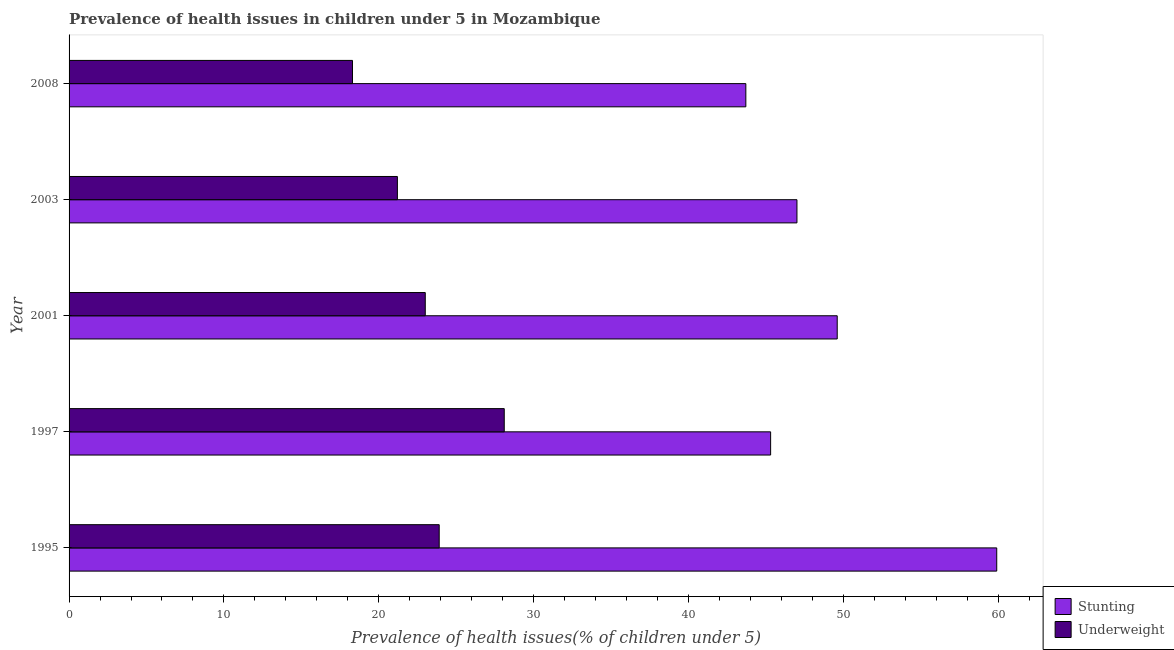Are the number of bars on each tick of the Y-axis equal?
Keep it short and to the point. Yes. How many bars are there on the 5th tick from the bottom?
Ensure brevity in your answer.  2. What is the percentage of stunted children in 1995?
Offer a very short reply. 59.9. Across all years, what is the maximum percentage of stunted children?
Keep it short and to the point. 59.9. Across all years, what is the minimum percentage of stunted children?
Ensure brevity in your answer.  43.7. In which year was the percentage of stunted children maximum?
Your response must be concise. 1995. What is the total percentage of stunted children in the graph?
Your response must be concise. 245.5. What is the difference between the percentage of stunted children in 1997 and that in 2008?
Give a very brief answer. 1.6. What is the difference between the percentage of stunted children in 1995 and the percentage of underweight children in 2003?
Offer a very short reply. 38.7. What is the average percentage of stunted children per year?
Your response must be concise. 49.1. What is the ratio of the percentage of stunted children in 2001 to that in 2003?
Make the answer very short. 1.05. Is the percentage of stunted children in 1997 less than that in 2001?
Make the answer very short. Yes. Is the difference between the percentage of stunted children in 2001 and 2008 greater than the difference between the percentage of underweight children in 2001 and 2008?
Your answer should be very brief. Yes. Is the sum of the percentage of underweight children in 1995 and 2008 greater than the maximum percentage of stunted children across all years?
Ensure brevity in your answer.  No. What does the 1st bar from the top in 1997 represents?
Your answer should be very brief. Underweight. What does the 2nd bar from the bottom in 1995 represents?
Give a very brief answer. Underweight. How many bars are there?
Make the answer very short. 10. How many years are there in the graph?
Your response must be concise. 5. What is the difference between two consecutive major ticks on the X-axis?
Ensure brevity in your answer.  10. Are the values on the major ticks of X-axis written in scientific E-notation?
Make the answer very short. No. Does the graph contain grids?
Your response must be concise. No. How many legend labels are there?
Your answer should be very brief. 2. How are the legend labels stacked?
Make the answer very short. Vertical. What is the title of the graph?
Keep it short and to the point. Prevalence of health issues in children under 5 in Mozambique. What is the label or title of the X-axis?
Your response must be concise. Prevalence of health issues(% of children under 5). What is the Prevalence of health issues(% of children under 5) in Stunting in 1995?
Offer a very short reply. 59.9. What is the Prevalence of health issues(% of children under 5) of Underweight in 1995?
Provide a succinct answer. 23.9. What is the Prevalence of health issues(% of children under 5) of Stunting in 1997?
Offer a terse response. 45.3. What is the Prevalence of health issues(% of children under 5) in Underweight in 1997?
Make the answer very short. 28.1. What is the Prevalence of health issues(% of children under 5) in Stunting in 2001?
Your answer should be very brief. 49.6. What is the Prevalence of health issues(% of children under 5) in Underweight in 2001?
Provide a succinct answer. 23. What is the Prevalence of health issues(% of children under 5) of Underweight in 2003?
Your response must be concise. 21.2. What is the Prevalence of health issues(% of children under 5) of Stunting in 2008?
Provide a short and direct response. 43.7. What is the Prevalence of health issues(% of children under 5) of Underweight in 2008?
Your answer should be compact. 18.3. Across all years, what is the maximum Prevalence of health issues(% of children under 5) in Stunting?
Offer a very short reply. 59.9. Across all years, what is the maximum Prevalence of health issues(% of children under 5) in Underweight?
Your answer should be compact. 28.1. Across all years, what is the minimum Prevalence of health issues(% of children under 5) in Stunting?
Ensure brevity in your answer.  43.7. Across all years, what is the minimum Prevalence of health issues(% of children under 5) in Underweight?
Ensure brevity in your answer.  18.3. What is the total Prevalence of health issues(% of children under 5) in Stunting in the graph?
Your answer should be very brief. 245.5. What is the total Prevalence of health issues(% of children under 5) of Underweight in the graph?
Your response must be concise. 114.5. What is the difference between the Prevalence of health issues(% of children under 5) in Underweight in 1995 and that in 1997?
Keep it short and to the point. -4.2. What is the difference between the Prevalence of health issues(% of children under 5) in Stunting in 1995 and that in 2001?
Make the answer very short. 10.3. What is the difference between the Prevalence of health issues(% of children under 5) of Underweight in 1995 and that in 2001?
Make the answer very short. 0.9. What is the difference between the Prevalence of health issues(% of children under 5) of Stunting in 1995 and that in 2003?
Your response must be concise. 12.9. What is the difference between the Prevalence of health issues(% of children under 5) of Underweight in 1995 and that in 2003?
Offer a terse response. 2.7. What is the difference between the Prevalence of health issues(% of children under 5) of Stunting in 1995 and that in 2008?
Provide a short and direct response. 16.2. What is the difference between the Prevalence of health issues(% of children under 5) of Underweight in 1995 and that in 2008?
Make the answer very short. 5.6. What is the difference between the Prevalence of health issues(% of children under 5) of Underweight in 1997 and that in 2003?
Your answer should be compact. 6.9. What is the difference between the Prevalence of health issues(% of children under 5) of Underweight in 1997 and that in 2008?
Provide a short and direct response. 9.8. What is the difference between the Prevalence of health issues(% of children under 5) in Stunting in 2001 and that in 2003?
Offer a very short reply. 2.6. What is the difference between the Prevalence of health issues(% of children under 5) in Underweight in 2001 and that in 2008?
Offer a terse response. 4.7. What is the difference between the Prevalence of health issues(% of children under 5) of Stunting in 1995 and the Prevalence of health issues(% of children under 5) of Underweight in 1997?
Provide a short and direct response. 31.8. What is the difference between the Prevalence of health issues(% of children under 5) of Stunting in 1995 and the Prevalence of health issues(% of children under 5) of Underweight in 2001?
Give a very brief answer. 36.9. What is the difference between the Prevalence of health issues(% of children under 5) of Stunting in 1995 and the Prevalence of health issues(% of children under 5) of Underweight in 2003?
Your answer should be compact. 38.7. What is the difference between the Prevalence of health issues(% of children under 5) in Stunting in 1995 and the Prevalence of health issues(% of children under 5) in Underweight in 2008?
Provide a succinct answer. 41.6. What is the difference between the Prevalence of health issues(% of children under 5) of Stunting in 1997 and the Prevalence of health issues(% of children under 5) of Underweight in 2001?
Your response must be concise. 22.3. What is the difference between the Prevalence of health issues(% of children under 5) in Stunting in 1997 and the Prevalence of health issues(% of children under 5) in Underweight in 2003?
Offer a very short reply. 24.1. What is the difference between the Prevalence of health issues(% of children under 5) in Stunting in 1997 and the Prevalence of health issues(% of children under 5) in Underweight in 2008?
Provide a short and direct response. 27. What is the difference between the Prevalence of health issues(% of children under 5) of Stunting in 2001 and the Prevalence of health issues(% of children under 5) of Underweight in 2003?
Give a very brief answer. 28.4. What is the difference between the Prevalence of health issues(% of children under 5) in Stunting in 2001 and the Prevalence of health issues(% of children under 5) in Underweight in 2008?
Offer a very short reply. 31.3. What is the difference between the Prevalence of health issues(% of children under 5) in Stunting in 2003 and the Prevalence of health issues(% of children under 5) in Underweight in 2008?
Your answer should be very brief. 28.7. What is the average Prevalence of health issues(% of children under 5) of Stunting per year?
Keep it short and to the point. 49.1. What is the average Prevalence of health issues(% of children under 5) in Underweight per year?
Offer a terse response. 22.9. In the year 2001, what is the difference between the Prevalence of health issues(% of children under 5) of Stunting and Prevalence of health issues(% of children under 5) of Underweight?
Keep it short and to the point. 26.6. In the year 2003, what is the difference between the Prevalence of health issues(% of children under 5) in Stunting and Prevalence of health issues(% of children under 5) in Underweight?
Make the answer very short. 25.8. In the year 2008, what is the difference between the Prevalence of health issues(% of children under 5) of Stunting and Prevalence of health issues(% of children under 5) of Underweight?
Offer a very short reply. 25.4. What is the ratio of the Prevalence of health issues(% of children under 5) of Stunting in 1995 to that in 1997?
Keep it short and to the point. 1.32. What is the ratio of the Prevalence of health issues(% of children under 5) of Underweight in 1995 to that in 1997?
Keep it short and to the point. 0.85. What is the ratio of the Prevalence of health issues(% of children under 5) of Stunting in 1995 to that in 2001?
Make the answer very short. 1.21. What is the ratio of the Prevalence of health issues(% of children under 5) in Underweight in 1995 to that in 2001?
Make the answer very short. 1.04. What is the ratio of the Prevalence of health issues(% of children under 5) of Stunting in 1995 to that in 2003?
Make the answer very short. 1.27. What is the ratio of the Prevalence of health issues(% of children under 5) in Underweight in 1995 to that in 2003?
Ensure brevity in your answer.  1.13. What is the ratio of the Prevalence of health issues(% of children under 5) in Stunting in 1995 to that in 2008?
Your answer should be compact. 1.37. What is the ratio of the Prevalence of health issues(% of children under 5) of Underweight in 1995 to that in 2008?
Give a very brief answer. 1.31. What is the ratio of the Prevalence of health issues(% of children under 5) in Stunting in 1997 to that in 2001?
Make the answer very short. 0.91. What is the ratio of the Prevalence of health issues(% of children under 5) of Underweight in 1997 to that in 2001?
Your answer should be very brief. 1.22. What is the ratio of the Prevalence of health issues(% of children under 5) of Stunting in 1997 to that in 2003?
Make the answer very short. 0.96. What is the ratio of the Prevalence of health issues(% of children under 5) in Underweight in 1997 to that in 2003?
Keep it short and to the point. 1.33. What is the ratio of the Prevalence of health issues(% of children under 5) in Stunting in 1997 to that in 2008?
Keep it short and to the point. 1.04. What is the ratio of the Prevalence of health issues(% of children under 5) of Underweight in 1997 to that in 2008?
Give a very brief answer. 1.54. What is the ratio of the Prevalence of health issues(% of children under 5) in Stunting in 2001 to that in 2003?
Make the answer very short. 1.06. What is the ratio of the Prevalence of health issues(% of children under 5) of Underweight in 2001 to that in 2003?
Offer a very short reply. 1.08. What is the ratio of the Prevalence of health issues(% of children under 5) of Stunting in 2001 to that in 2008?
Provide a short and direct response. 1.14. What is the ratio of the Prevalence of health issues(% of children under 5) of Underweight in 2001 to that in 2008?
Keep it short and to the point. 1.26. What is the ratio of the Prevalence of health issues(% of children under 5) of Stunting in 2003 to that in 2008?
Provide a succinct answer. 1.08. What is the ratio of the Prevalence of health issues(% of children under 5) in Underweight in 2003 to that in 2008?
Your answer should be compact. 1.16. What is the difference between the highest and the second highest Prevalence of health issues(% of children under 5) of Stunting?
Your answer should be very brief. 10.3. What is the difference between the highest and the lowest Prevalence of health issues(% of children under 5) of Stunting?
Provide a succinct answer. 16.2. What is the difference between the highest and the lowest Prevalence of health issues(% of children under 5) in Underweight?
Your response must be concise. 9.8. 